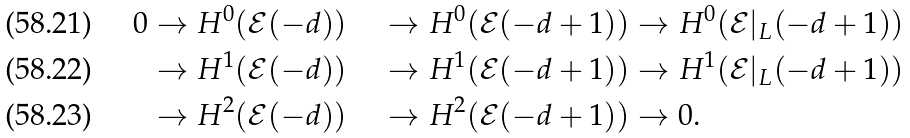<formula> <loc_0><loc_0><loc_500><loc_500>0 & \to H ^ { 0 } ( \mathcal { E } ( - d ) ) & \to H ^ { 0 } ( \mathcal { E } ( - d + 1 ) ) & \to H ^ { 0 } ( \mathcal { E } | _ { L } ( - d + 1 ) ) \\ & \to H ^ { 1 } ( \mathcal { E } ( - d ) ) & \to H ^ { 1 } ( \mathcal { E } ( - d + 1 ) ) & \to H ^ { 1 } ( \mathcal { E } | _ { L } ( - d + 1 ) ) \\ & \to H ^ { 2 } ( \mathcal { E } ( - d ) ) & \to H ^ { 2 } ( \mathcal { E } ( - d + 1 ) ) & \to 0 .</formula> 